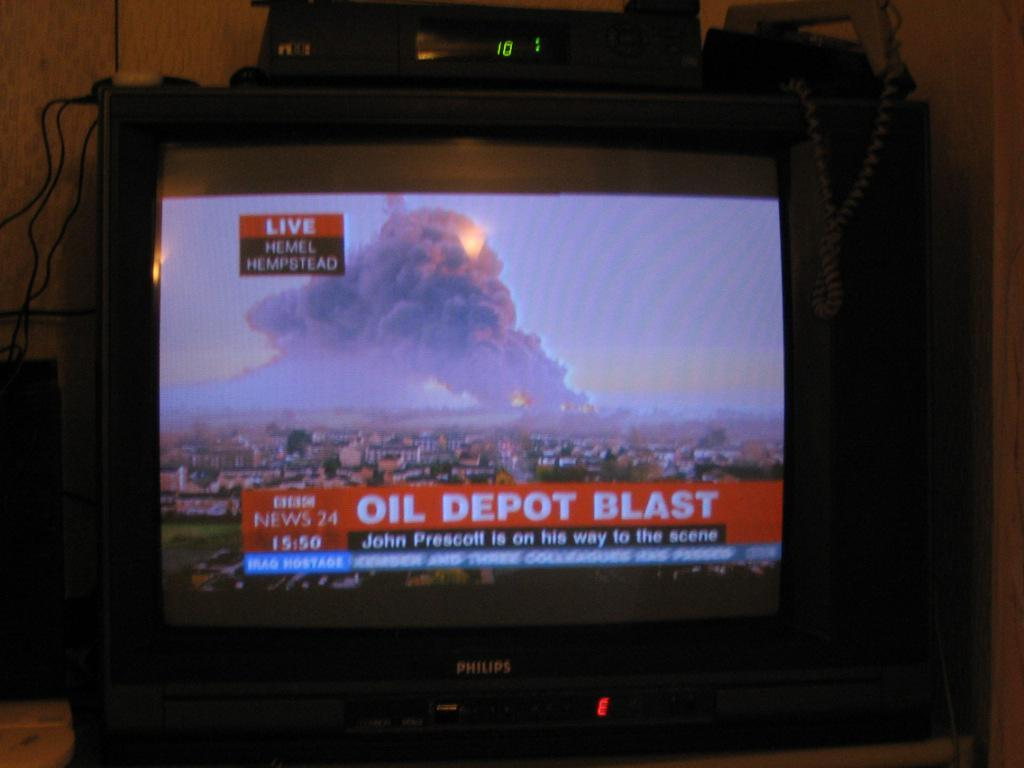<image>
Write a terse but informative summary of the picture. A news report about an oil depot blast 